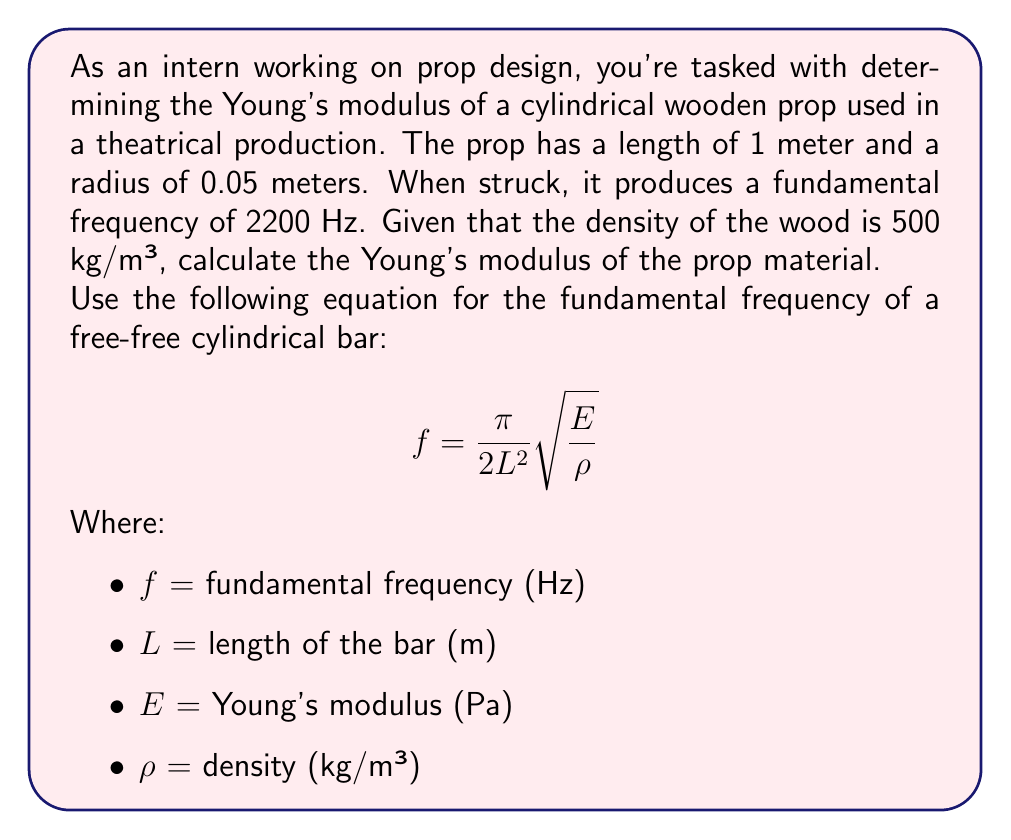Can you answer this question? To solve this problem, we'll use the given equation and the provided information to calculate the Young's modulus (E) of the wooden prop.

Given:
- Length (L) = 1 m
- Radius = 0.05 m (not needed for this calculation)
- Fundamental frequency (f) = 2200 Hz
- Density (ρ) = 500 kg/m³

Step 1: Rearrange the equation to solve for E.
$$f = \frac{\pi}{2L^2}\sqrt{\frac{E}{\rho}}$$
$$f^2 = \frac{\pi^2}{4L^4}\frac{E}{\rho}$$
$$E = \frac{4L^4f^2\rho}{\pi^2}$$

Step 2: Substitute the known values into the equation.
$$E = \frac{4 \cdot (1\text{ m})^4 \cdot (2200\text{ Hz})^2 \cdot 500\text{ kg/m³}}{\pi^2}$$

Step 3: Calculate the result.
$$E = \frac{4 \cdot 1 \cdot 2200^2 \cdot 500}{\pi^2} \text{ Pa}$$
$$E = \frac{9.68 \times 10^9}{\pi^2} \text{ Pa}$$
$$E \approx 9.79 \times 10^8 \text{ Pa}$$

Step 4: Convert the result to GPa for a more common representation.
$$E \approx 9.79 \times 10^8 \text{ Pa} \cdot \frac{1 \text{ GPa}}{10^9 \text{ Pa}} \approx 0.979 \text{ GPa}$$
Answer: 0.979 GPa 